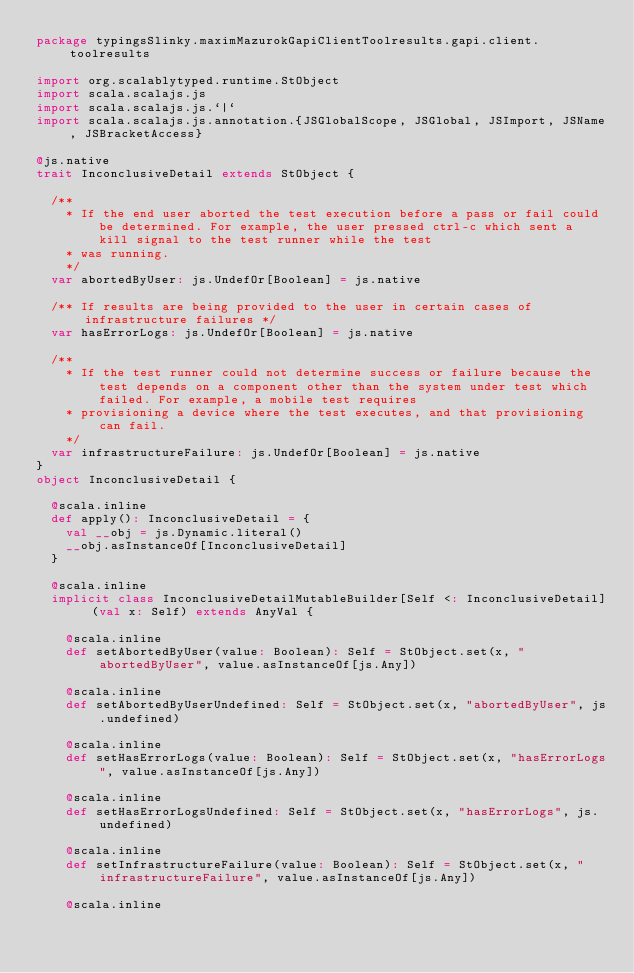Convert code to text. <code><loc_0><loc_0><loc_500><loc_500><_Scala_>package typingsSlinky.maximMazurokGapiClientToolresults.gapi.client.toolresults

import org.scalablytyped.runtime.StObject
import scala.scalajs.js
import scala.scalajs.js.`|`
import scala.scalajs.js.annotation.{JSGlobalScope, JSGlobal, JSImport, JSName, JSBracketAccess}

@js.native
trait InconclusiveDetail extends StObject {
  
  /**
    * If the end user aborted the test execution before a pass or fail could be determined. For example, the user pressed ctrl-c which sent a kill signal to the test runner while the test
    * was running.
    */
  var abortedByUser: js.UndefOr[Boolean] = js.native
  
  /** If results are being provided to the user in certain cases of infrastructure failures */
  var hasErrorLogs: js.UndefOr[Boolean] = js.native
  
  /**
    * If the test runner could not determine success or failure because the test depends on a component other than the system under test which failed. For example, a mobile test requires
    * provisioning a device where the test executes, and that provisioning can fail.
    */
  var infrastructureFailure: js.UndefOr[Boolean] = js.native
}
object InconclusiveDetail {
  
  @scala.inline
  def apply(): InconclusiveDetail = {
    val __obj = js.Dynamic.literal()
    __obj.asInstanceOf[InconclusiveDetail]
  }
  
  @scala.inline
  implicit class InconclusiveDetailMutableBuilder[Self <: InconclusiveDetail] (val x: Self) extends AnyVal {
    
    @scala.inline
    def setAbortedByUser(value: Boolean): Self = StObject.set(x, "abortedByUser", value.asInstanceOf[js.Any])
    
    @scala.inline
    def setAbortedByUserUndefined: Self = StObject.set(x, "abortedByUser", js.undefined)
    
    @scala.inline
    def setHasErrorLogs(value: Boolean): Self = StObject.set(x, "hasErrorLogs", value.asInstanceOf[js.Any])
    
    @scala.inline
    def setHasErrorLogsUndefined: Self = StObject.set(x, "hasErrorLogs", js.undefined)
    
    @scala.inline
    def setInfrastructureFailure(value: Boolean): Self = StObject.set(x, "infrastructureFailure", value.asInstanceOf[js.Any])
    
    @scala.inline</code> 